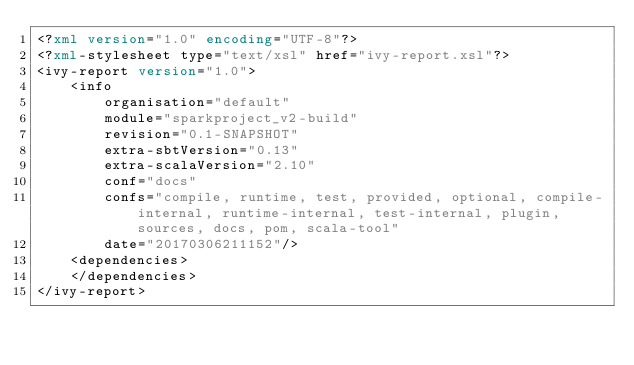<code> <loc_0><loc_0><loc_500><loc_500><_XML_><?xml version="1.0" encoding="UTF-8"?>
<?xml-stylesheet type="text/xsl" href="ivy-report.xsl"?>
<ivy-report version="1.0">
	<info
		organisation="default"
		module="sparkproject_v2-build"
		revision="0.1-SNAPSHOT"
		extra-sbtVersion="0.13"
		extra-scalaVersion="2.10"
		conf="docs"
		confs="compile, runtime, test, provided, optional, compile-internal, runtime-internal, test-internal, plugin, sources, docs, pom, scala-tool"
		date="20170306211152"/>
	<dependencies>
	</dependencies>
</ivy-report>
</code> 